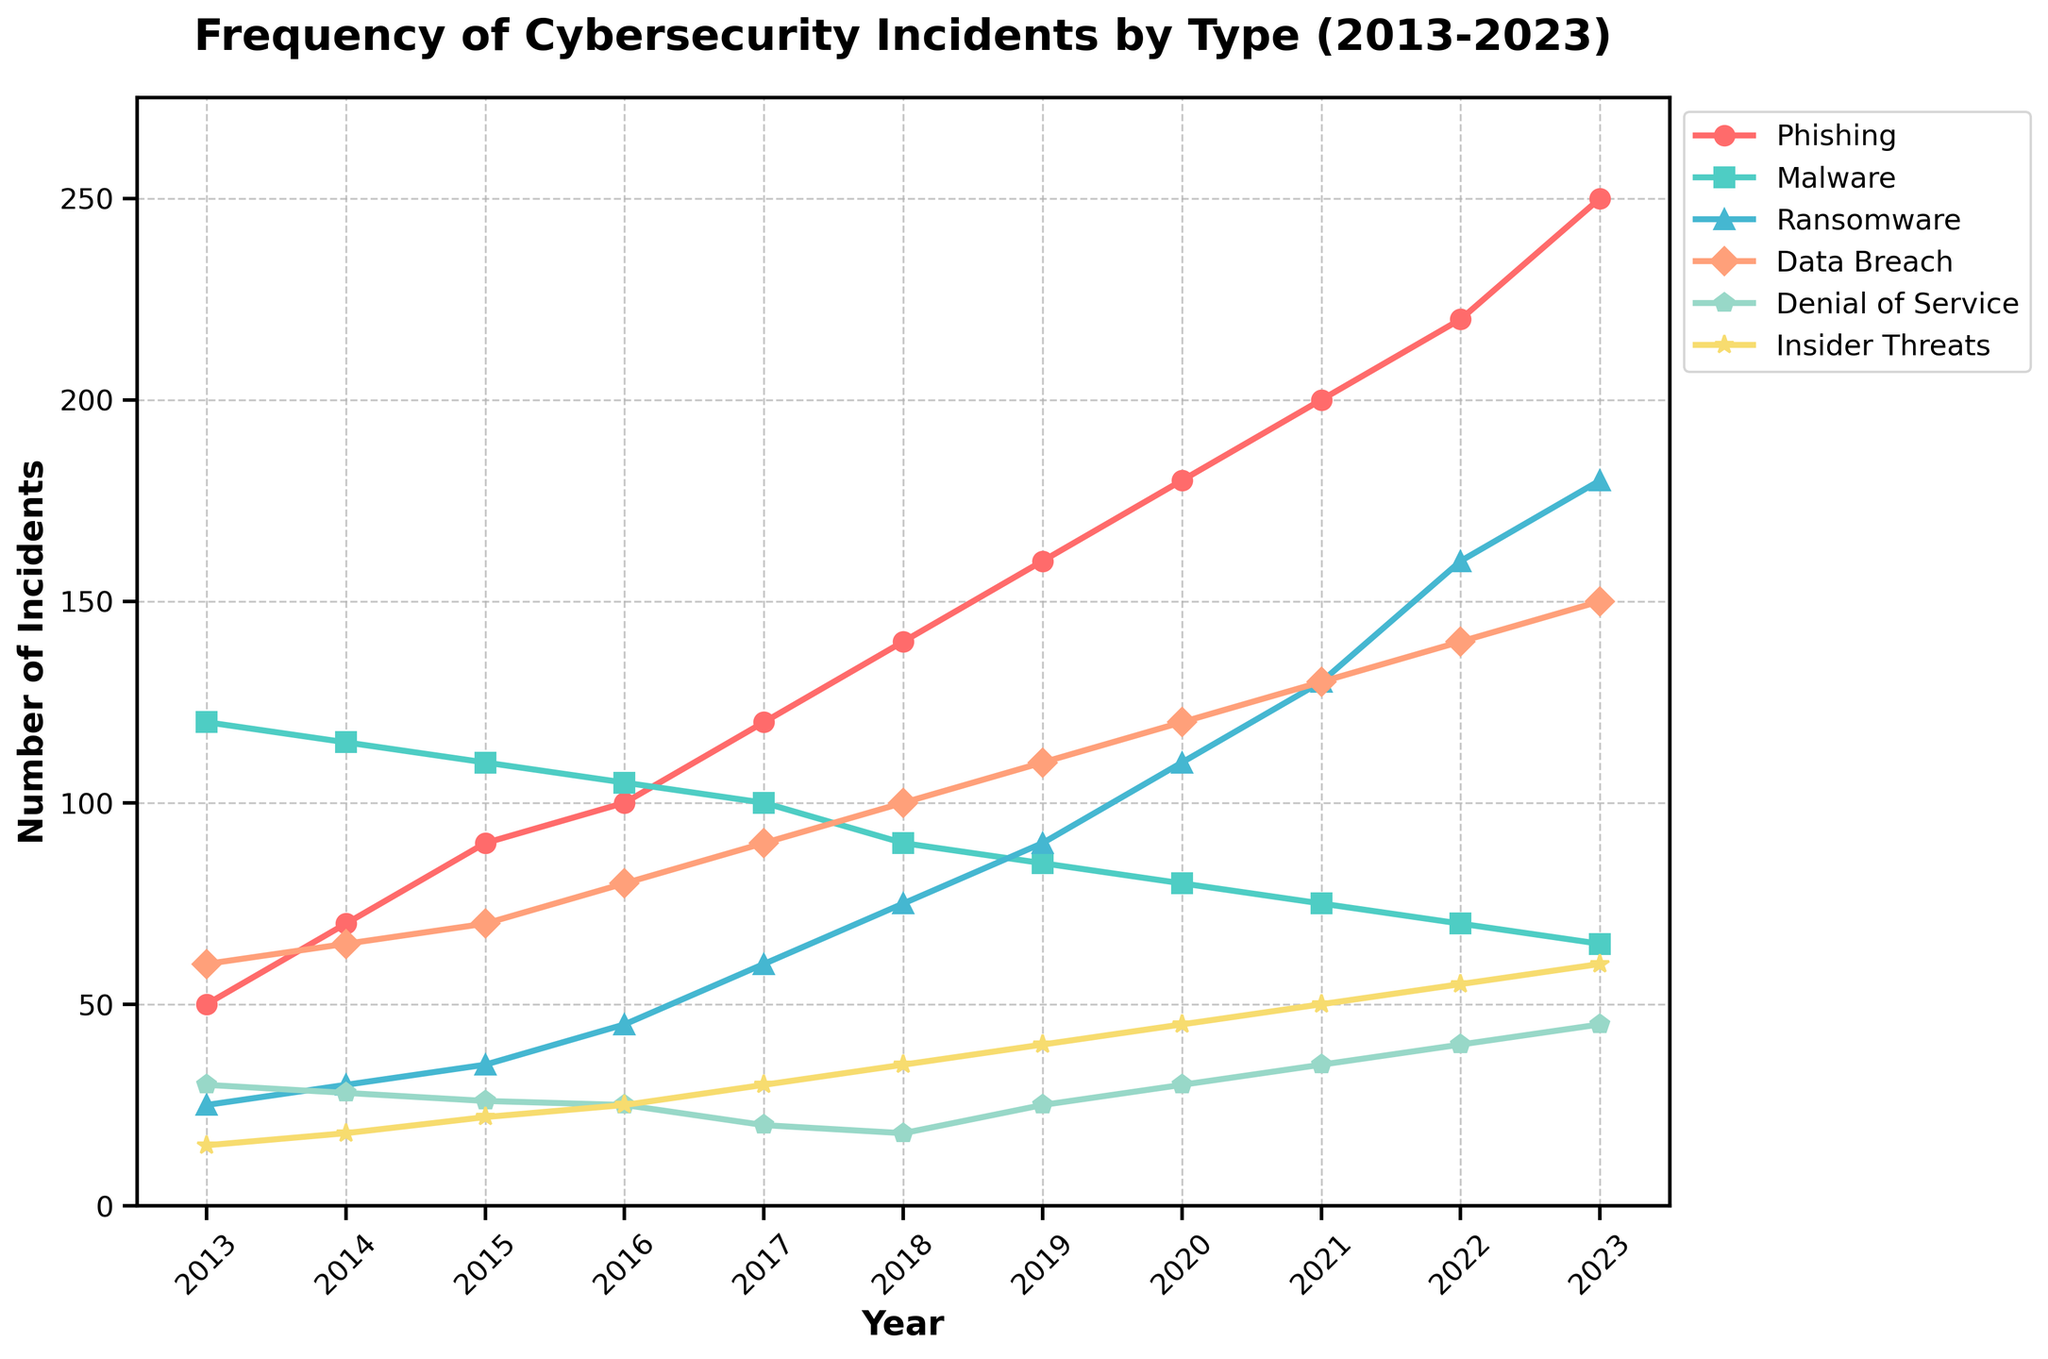What is the title of the plot? The title of the plot is located at the top center of the figure. It provides a summary of what the figure represents.
Answer: Frequency of Cybersecurity Incidents by Type (2013-2023) How many types of cybersecurity incidents are plotted? Each line on the time series plot represents a different type of cybersecurity incident. The legend on the right side of the plot identifies these types. Count the unique types listed in the legend.
Answer: 6 What is the trend for Phishing incidents over the last decade? Look at the line representing Phishing incidents from 2013 to 2023. Observe whether it increases, decreases, or stays constant over time.
Answer: Increasing Which type of incident had the highest number in 2023? Identify the 2023 data points from the plot. Compare the values for each type of incident to see which one is the highest.
Answer: Phishing What is the difference in the number of Malware incidents between 2013 and 2023? Find the 2013 and 2023 values for Malware incidents from the plot. Calculate the difference by subtracting the 2013 value from the 2023 value.
Answer: 55 Which year saw the highest number of Denial of Service incidents? Identify the peak in the line representing Denial of Service incidents. Locate the corresponding year for this peak value.
Answer: 2023 How does the frequency of Data Breaches compare to Insider Threats in 2020? Locate the data points for both Data Breaches and Insider Threats in 2020. Compare the two values to determine which one is higher.
Answer: Data Breaches are higher What is the average number of Ransomware incidents over the decade? Identify the values for Ransomware incidents for each year from 2013 to 2023. Sum these values and divide by the total number of years (11) to find the average.
Answer: 86.36 Which type of incident had the most consistent number of occurrences over the years? Look at the lines representing each type of incident. Determine which line shows the least variation and stays relatively steady over the years.
Answer: Denial of Service Between which two consecutive years did Phishing incidents see the largest increase? Look at the year-to-year changes in the Phishing line. Identify the two consecutive years with the biggest increase in the number of incidents.
Answer: 2019-2020 